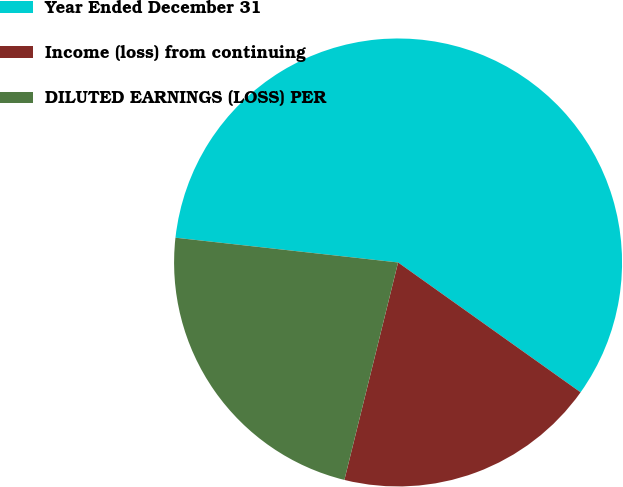Convert chart. <chart><loc_0><loc_0><loc_500><loc_500><pie_chart><fcel>Year Ended December 31<fcel>Income (loss) from continuing<fcel>DILUTED EARNINGS (LOSS) PER<nl><fcel>58.08%<fcel>19.01%<fcel>22.91%<nl></chart> 